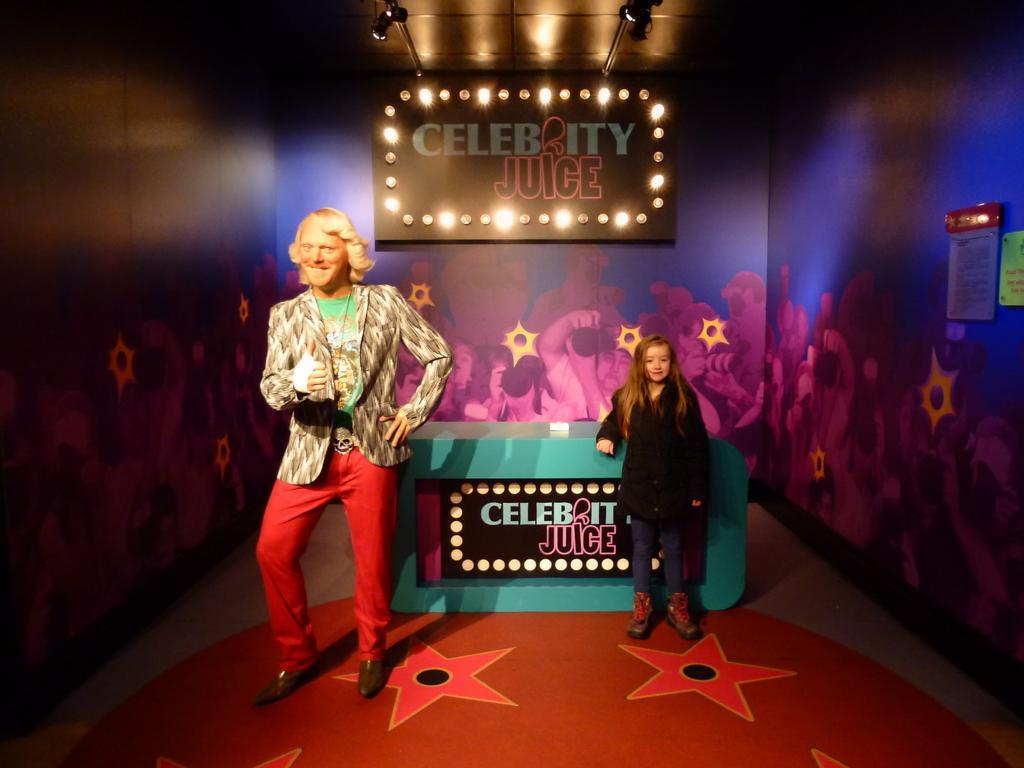In one or two sentences, can you explain what this image depicts? In this image we an see a man and a child standing on the floor. On the right side we can see some boards on a wall. On the backside we can see a board with lights and some text on it and a roof with some ceiling lights. 